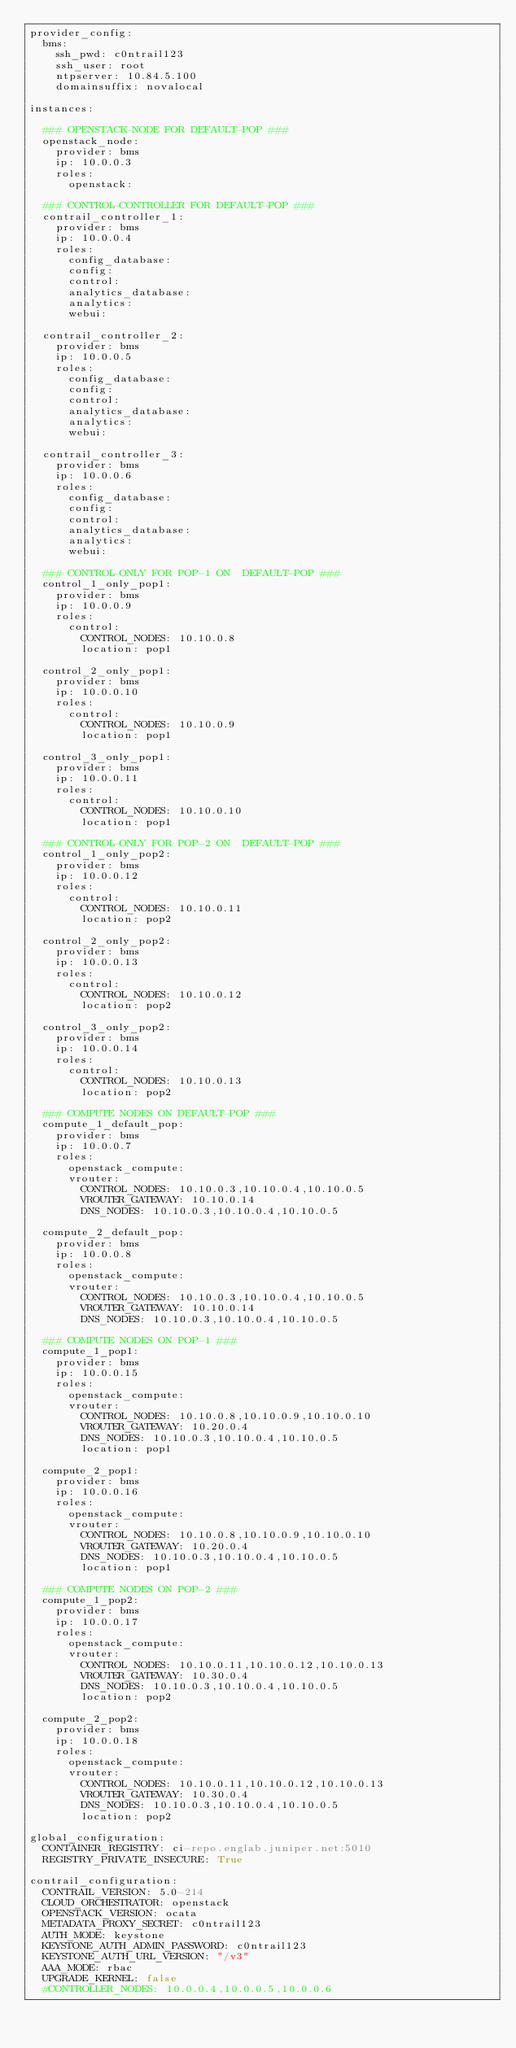<code> <loc_0><loc_0><loc_500><loc_500><_YAML_>provider_config:
  bms:
    ssh_pwd: c0ntrail123
    ssh_user: root
    ntpserver: 10.84.5.100
    domainsuffix: novalocal

instances:

  ### OPENSTACK-NODE FOR DEFAULT-POP ###
  openstack_node:
    provider: bms
    ip: 10.0.0.3
    roles:
      openstack:

  ### CONTROL-CONTROLLER FOR DEFAULT-POP ###
  contrail_controller_1:
    provider: bms
    ip: 10.0.0.4
    roles:
      config_database:
      config:
      control:
      analytics_database:
      analytics:
      webui:

  contrail_controller_2:
    provider: bms
    ip: 10.0.0.5
    roles:
      config_database:
      config:
      control:
      analytics_database:
      analytics:
      webui:

  contrail_controller_3:
    provider: bms
    ip: 10.0.0.6
    roles:
      config_database:
      config:
      control:
      analytics_database:
      analytics:
      webui:

  ### CONTROL-ONLY FOR POP-1 ON  DEFAULT-POP ###
  control_1_only_pop1:
    provider: bms
    ip: 10.0.0.9
    roles:
      control:
        CONTROL_NODES: 10.10.0.8
        location: pop1

  control_2_only_pop1:
    provider: bms
    ip: 10.0.0.10
    roles:
      control:
        CONTROL_NODES: 10.10.0.9
        location: pop1

  control_3_only_pop1:
    provider: bms
    ip: 10.0.0.11
    roles:
      control:
        CONTROL_NODES: 10.10.0.10
        location: pop1

  ### CONTROL-ONLY FOR POP-2 ON  DEFAULT-POP ###
  control_1_only_pop2:
    provider: bms
    ip: 10.0.0.12
    roles:
      control:
        CONTROL_NODES: 10.10.0.11
        location: pop2

  control_2_only_pop2:
    provider: bms
    ip: 10.0.0.13
    roles:
      control:
        CONTROL_NODES: 10.10.0.12
        location: pop2

  control_3_only_pop2:
    provider: bms
    ip: 10.0.0.14
    roles:
      control:
        CONTROL_NODES: 10.10.0.13
        location: pop2

  ### COMPUTE NODES ON DEFAULT-POP ###
  compute_1_default_pop:
    provider: bms
    ip: 10.0.0.7
    roles:
      openstack_compute:
      vrouter:
        CONTROL_NODES: 10.10.0.3,10.10.0.4,10.10.0.5
        VROUTER_GATEWAY: 10.10.0.14
        DNS_NODES: 10.10.0.3,10.10.0.4,10.10.0.5

  compute_2_default_pop:
    provider: bms
    ip: 10.0.0.8
    roles:
      openstack_compute:
      vrouter:
        CONTROL_NODES: 10.10.0.3,10.10.0.4,10.10.0.5
        VROUTER_GATEWAY: 10.10.0.14
        DNS_NODES: 10.10.0.3,10.10.0.4,10.10.0.5

  ### COMPUTE NODES ON POP-1 ###
  compute_1_pop1:
    provider: bms
    ip: 10.0.0.15
    roles:
      openstack_compute:
      vrouter:
        CONTROL_NODES: 10.10.0.8,10.10.0.9,10.10.0.10
        VROUTER_GATEWAY: 10.20.0.4
        DNS_NODES: 10.10.0.3,10.10.0.4,10.10.0.5
        location: pop1

  compute_2_pop1:
    provider: bms
    ip: 10.0.0.16
    roles:
      openstack_compute:
      vrouter:
        CONTROL_NODES: 10.10.0.8,10.10.0.9,10.10.0.10
        VROUTER_GATEWAY: 10.20.0.4
        DNS_NODES: 10.10.0.3,10.10.0.4,10.10.0.5
        location: pop1

  ### COMPUTE NODES ON POP-2 ###
  compute_1_pop2:
    provider: bms
    ip: 10.0.0.17
    roles:
      openstack_compute:
      vrouter:
        CONTROL_NODES: 10.10.0.11,10.10.0.12,10.10.0.13
        VROUTER_GATEWAY: 10.30.0.4
        DNS_NODES: 10.10.0.3,10.10.0.4,10.10.0.5
        location: pop2

  compute_2_pop2:
    provider: bms
    ip: 10.0.0.18
    roles:
      openstack_compute:
      vrouter:
        CONTROL_NODES: 10.10.0.11,10.10.0.12,10.10.0.13
        VROUTER_GATEWAY: 10.30.0.4
        DNS_NODES: 10.10.0.3,10.10.0.4,10.10.0.5
        location: pop2

global_configuration:
  CONTAINER_REGISTRY: ci-repo.englab.juniper.net:5010
  REGISTRY_PRIVATE_INSECURE: True

contrail_configuration:
  CONTRAIL_VERSION: 5.0-214
  CLOUD_ORCHESTRATOR: openstack
  OPENSTACK_VERSION: ocata
  METADATA_PROXY_SECRET: c0ntrail123
  AUTH_MODE: keystone
  KEYSTONE_AUTH_ADMIN_PASSWORD: c0ntrail123
  KEYSTONE_AUTH_URL_VERSION: "/v3"
  AAA_MODE: rbac
  UPGRADE_KERNEL: false
  #CONTROLLER_NODES: 10.0.0.4,10.0.0.5,10.0.0.6</code> 